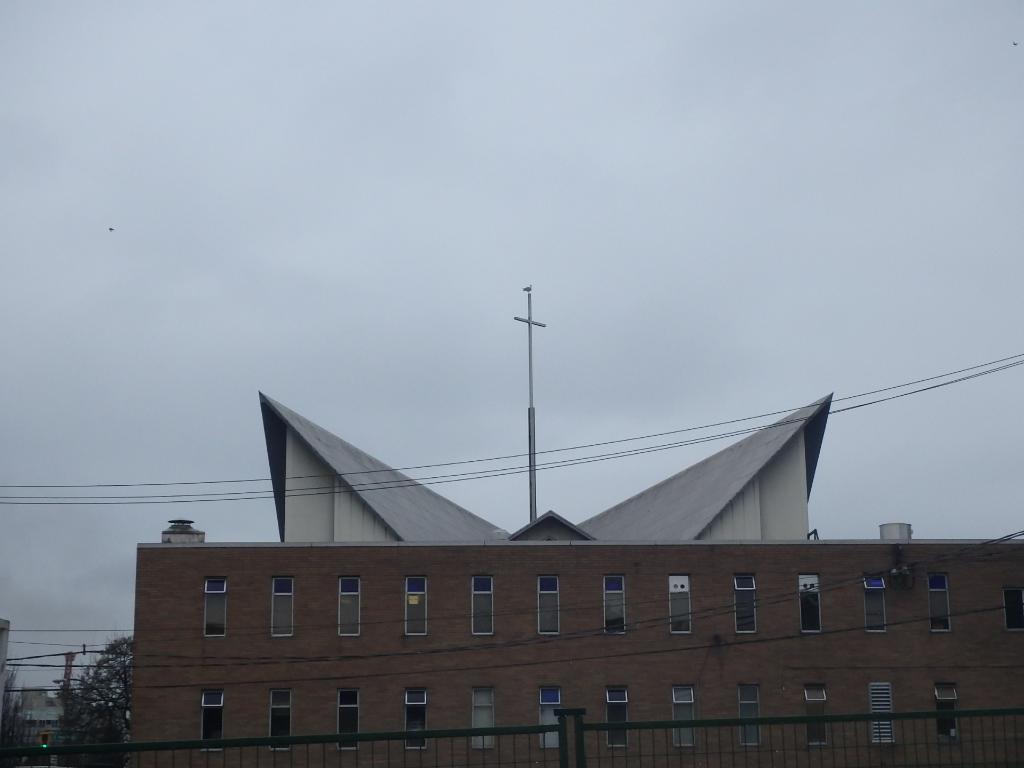In one or two sentences, can you explain what this image depicts? In this image we can see building, poles, grill, electric cables, windows, trees and sky in the background. 